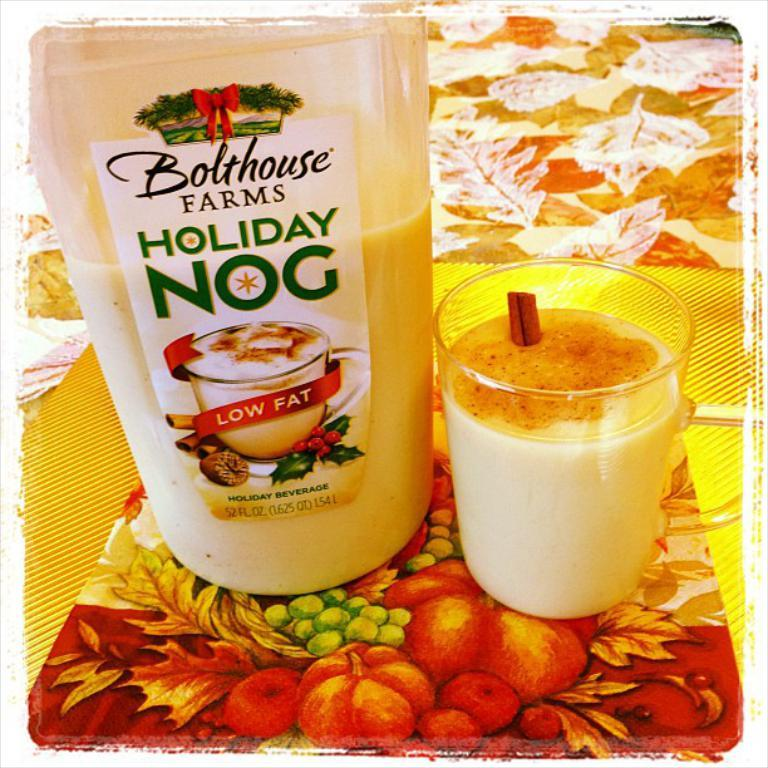What is present on the surface beneath the glass and bottle in the image? The surface beneath the glass and bottle is yellow and has a design of fruits on it. What else can be seen in the image besides the glass and bottle? There is a picture of names and logos on the bottle. Can you see a squirrel interacting with the cloud in the image? There is no squirrel or cloud present in the image. What type of trade is being conducted in the image? There is no trade being conducted in the image; it features a glass, a bottle, and a yellow surface with a fruit design. 